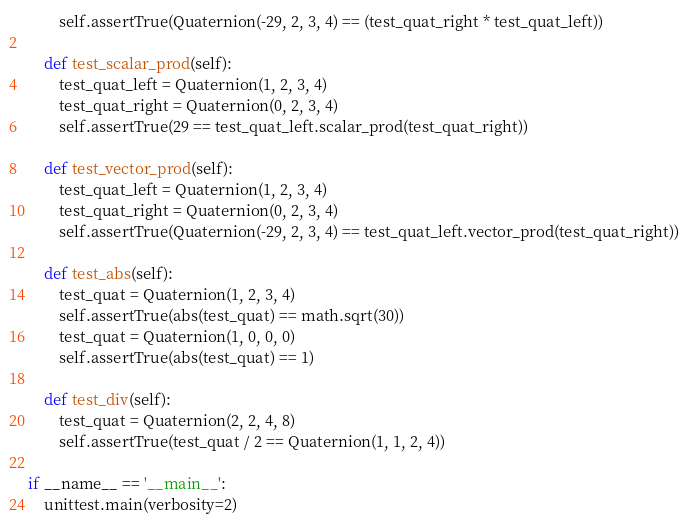Convert code to text. <code><loc_0><loc_0><loc_500><loc_500><_Python_>        self.assertTrue(Quaternion(-29, 2, 3, 4) == (test_quat_right * test_quat_left))

    def test_scalar_prod(self):
        test_quat_left = Quaternion(1, 2, 3, 4)
        test_quat_right = Quaternion(0, 2, 3, 4)
        self.assertTrue(29 == test_quat_left.scalar_prod(test_quat_right))

    def test_vector_prod(self):
        test_quat_left = Quaternion(1, 2, 3, 4)
        test_quat_right = Quaternion(0, 2, 3, 4)
        self.assertTrue(Quaternion(-29, 2, 3, 4) == test_quat_left.vector_prod(test_quat_right))

    def test_abs(self):
        test_quat = Quaternion(1, 2, 3, 4)
        self.assertTrue(abs(test_quat) == math.sqrt(30))
        test_quat = Quaternion(1, 0, 0, 0)
        self.assertTrue(abs(test_quat) == 1)

    def test_div(self):
        test_quat = Quaternion(2, 2, 4, 8)
        self.assertTrue(test_quat / 2 == Quaternion(1, 1, 2, 4))

if __name__ == '__main__':
    unittest.main(verbosity=2)</code> 